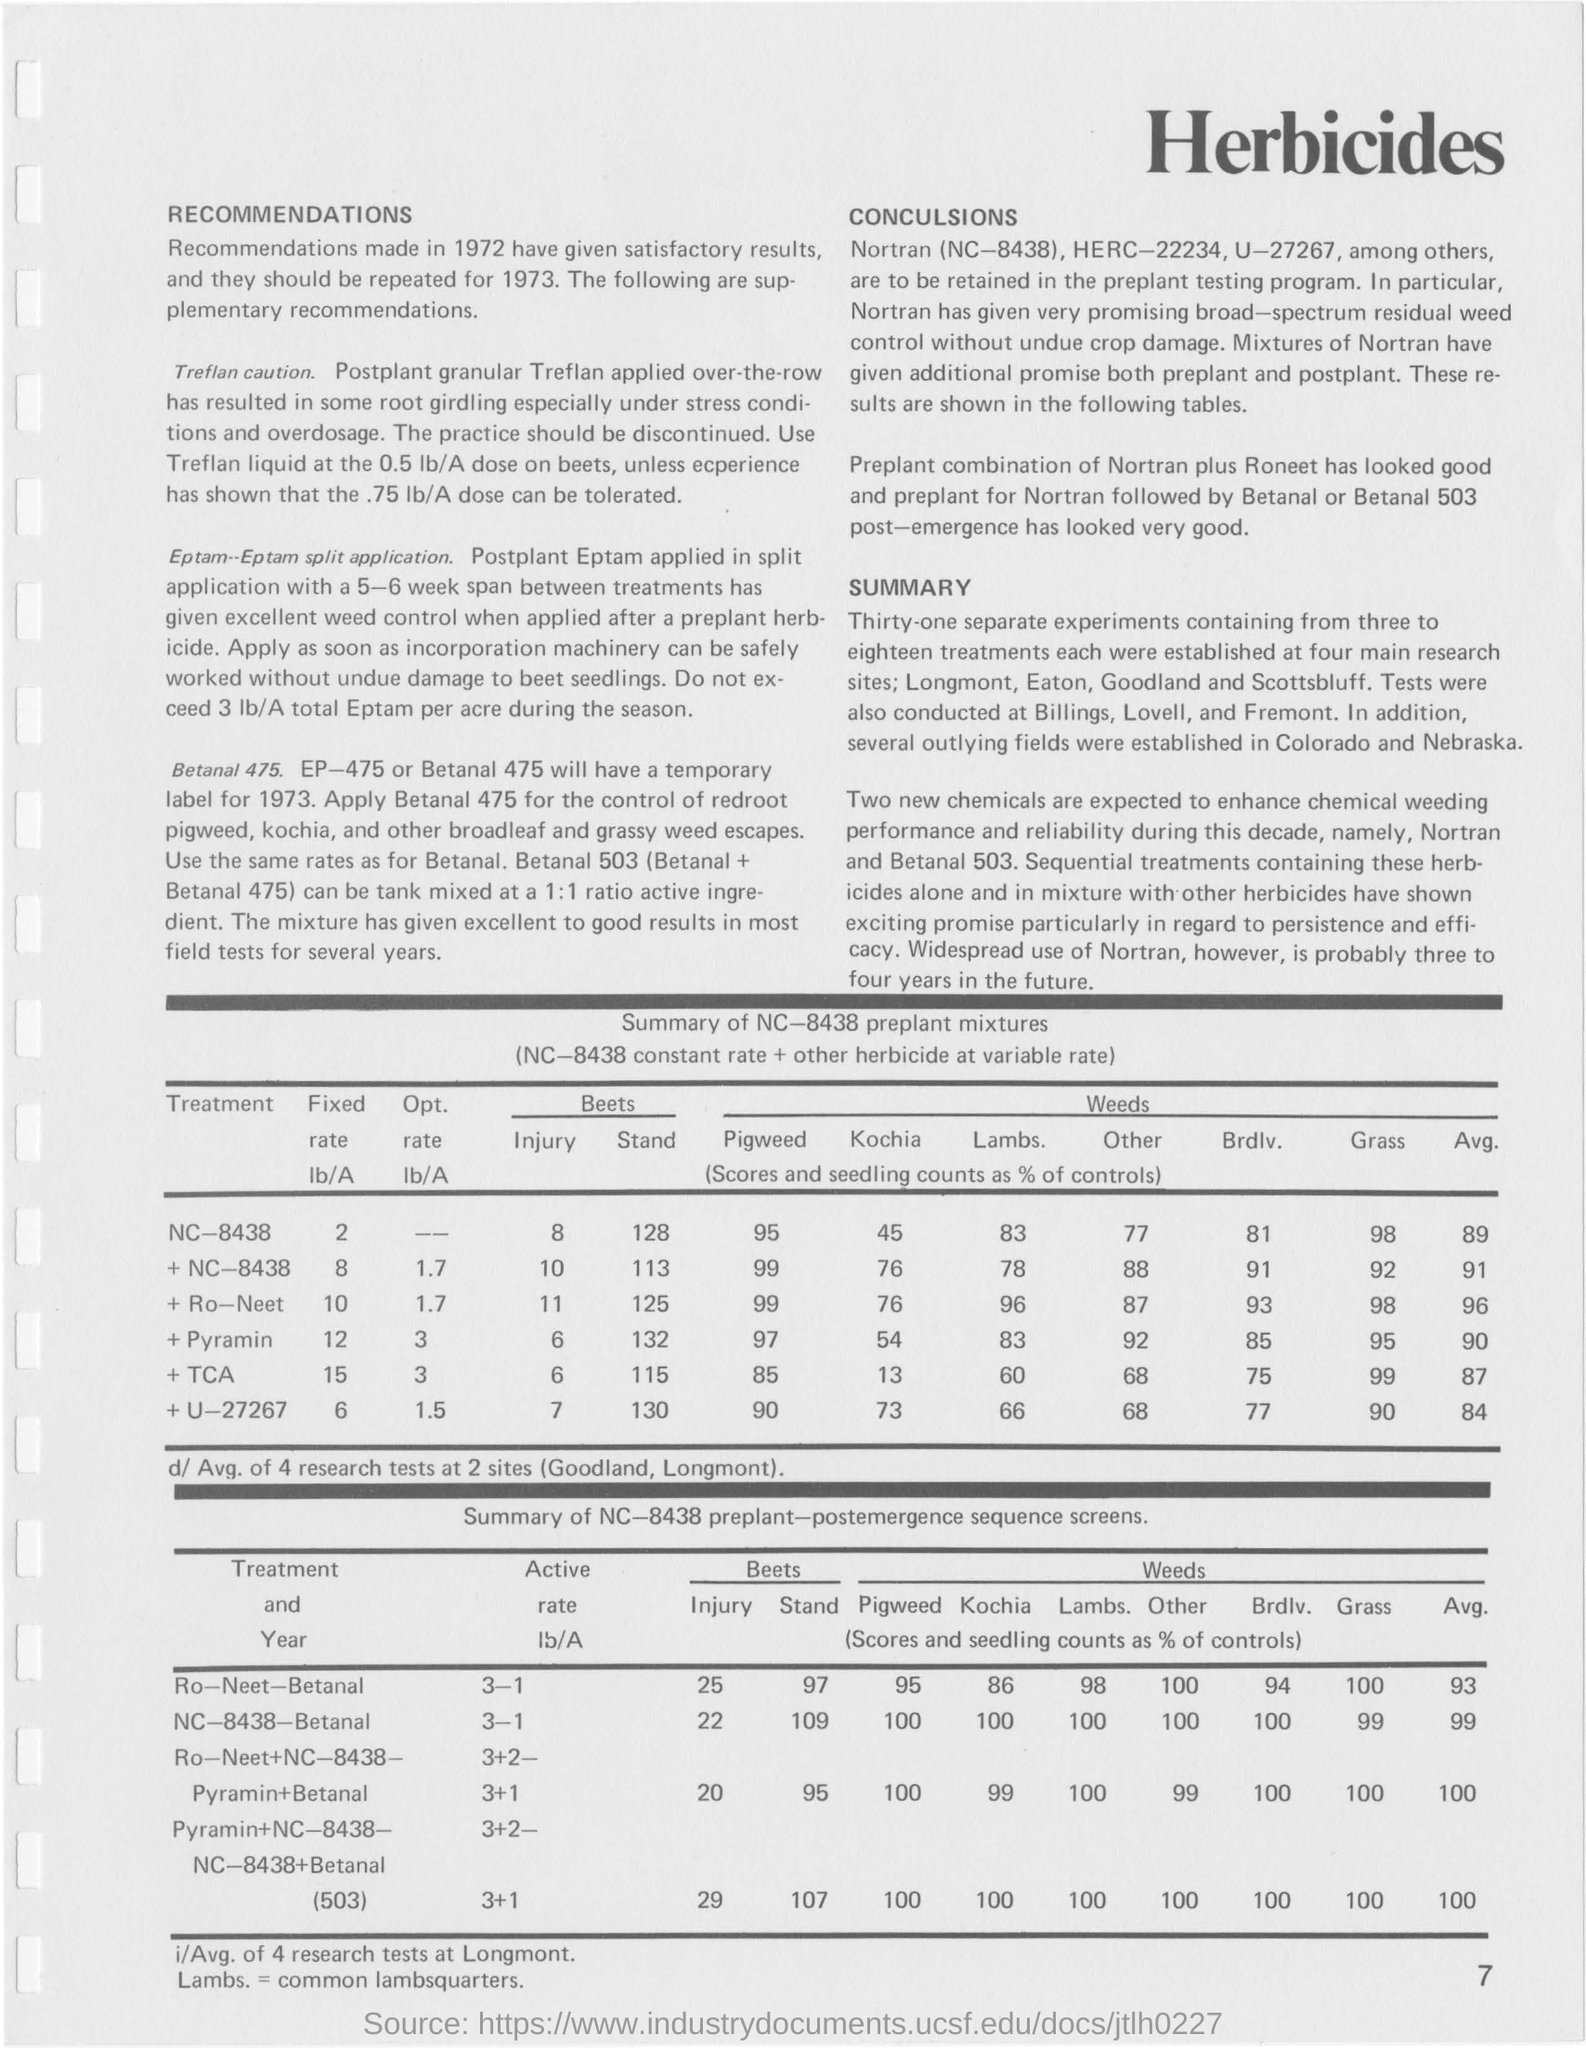What is the title of the first table from top?
Your response must be concise. Summary of NC-8438 preplant mixtures. What is the title of the second table from top?
Provide a succinct answer. Summary of NC-8438 preplant-postemergence sequence screens. What is the fixed rate for the treatment nc-8438?
Offer a terse response. 2. Which are the four main research sites?
Offer a very short reply. Longmont, Eaton, Goodland and Scottsbluff. Which will have temporary label for 1973?
Your answer should be very brief. EP-475 or Betanal 475. 